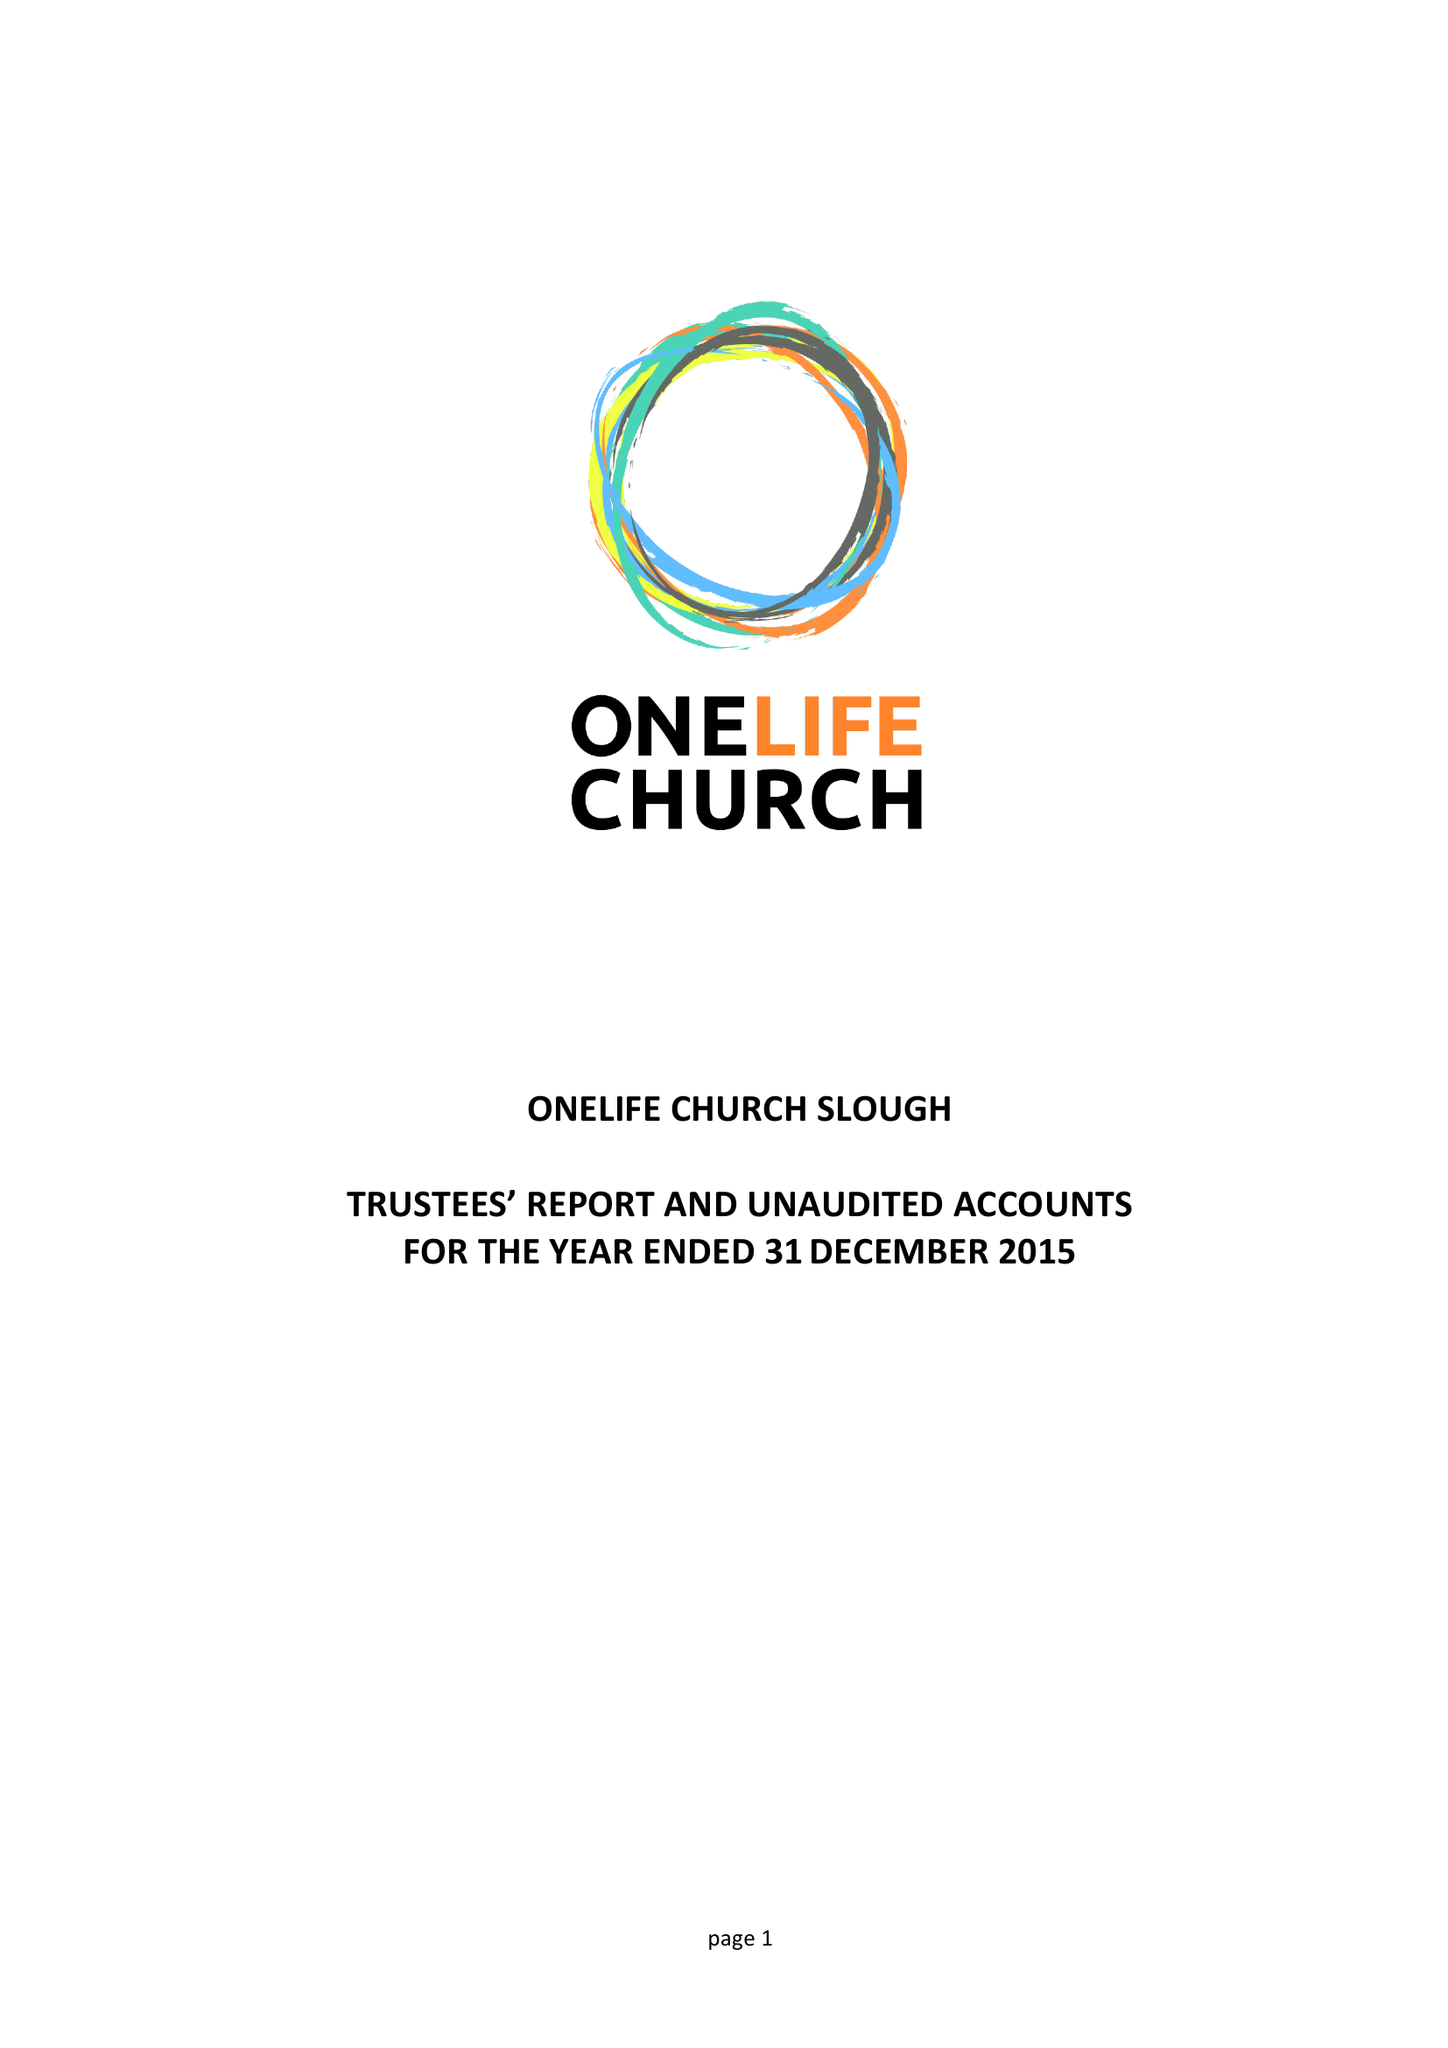What is the value for the address__post_town?
Answer the question using a single word or phrase. SLOUGH 